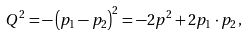Convert formula to latex. <formula><loc_0><loc_0><loc_500><loc_500>Q ^ { 2 } = - \left ( p _ { 1 } - p _ { 2 } \right ) ^ { 2 } = - 2 p ^ { 2 } + 2 p _ { 1 } \cdot p _ { 2 } \, ,</formula> 